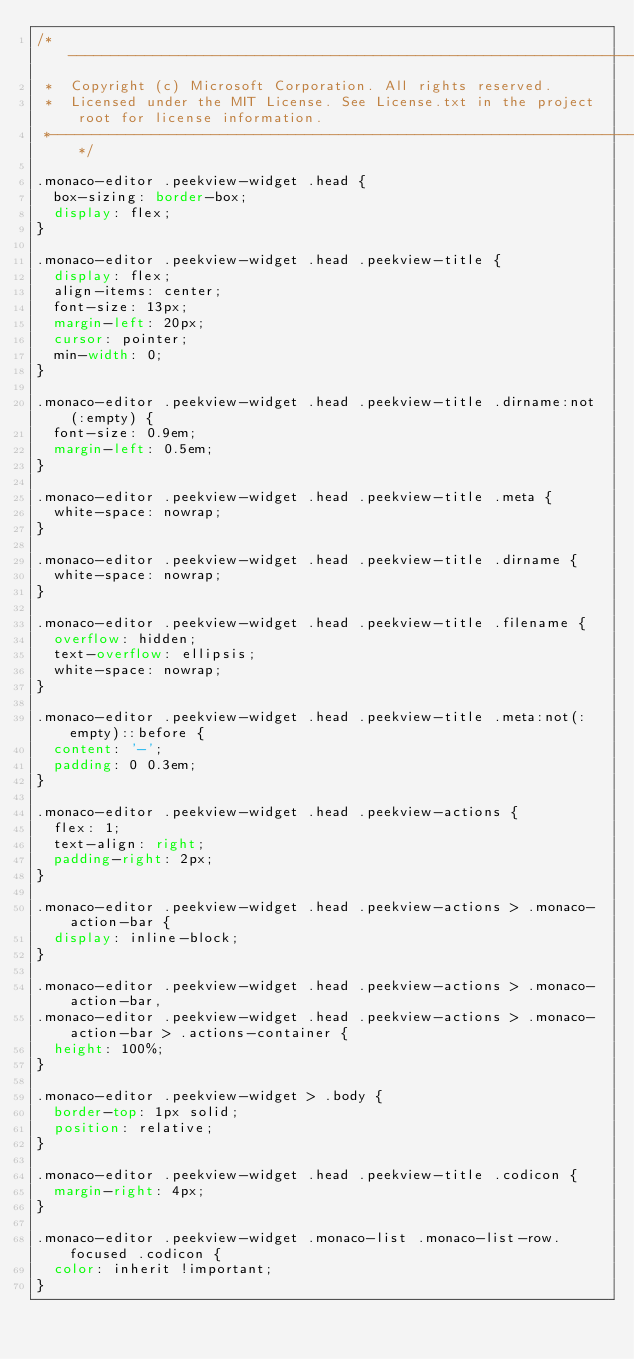<code> <loc_0><loc_0><loc_500><loc_500><_CSS_>/*---------------------------------------------------------------------------------------------
 *  Copyright (c) Microsoft Corporation. All rights reserved.
 *  Licensed under the MIT License. See License.txt in the project root for license information.
 *--------------------------------------------------------------------------------------------*/

.monaco-editor .peekview-widget .head {
	box-sizing: border-box;
	display: flex;
}

.monaco-editor .peekview-widget .head .peekview-title {
	display: flex;
	align-items: center;
	font-size: 13px;
	margin-left: 20px;
	cursor: pointer;
	min-width: 0;
}

.monaco-editor .peekview-widget .head .peekview-title .dirname:not(:empty) {
	font-size: 0.9em;
	margin-left: 0.5em;
}

.monaco-editor .peekview-widget .head .peekview-title .meta {
	white-space: nowrap;
}

.monaco-editor .peekview-widget .head .peekview-title .dirname {
	white-space: nowrap;
}

.monaco-editor .peekview-widget .head .peekview-title .filename {
	overflow: hidden;
	text-overflow: ellipsis;
	white-space: nowrap;
}

.monaco-editor .peekview-widget .head .peekview-title .meta:not(:empty)::before {
	content: '-';
	padding: 0 0.3em;
}

.monaco-editor .peekview-widget .head .peekview-actions {
	flex: 1;
	text-align: right;
	padding-right: 2px;
}

.monaco-editor .peekview-widget .head .peekview-actions > .monaco-action-bar {
	display: inline-block;
}

.monaco-editor .peekview-widget .head .peekview-actions > .monaco-action-bar,
.monaco-editor .peekview-widget .head .peekview-actions > .monaco-action-bar > .actions-container {
	height: 100%;
}

.monaco-editor .peekview-widget > .body {
	border-top: 1px solid;
	position: relative;
}

.monaco-editor .peekview-widget .head .peekview-title .codicon {
	margin-right: 4px;
}

.monaco-editor .peekview-widget .monaco-list .monaco-list-row.focused .codicon {
	color: inherit !important;
}
</code> 